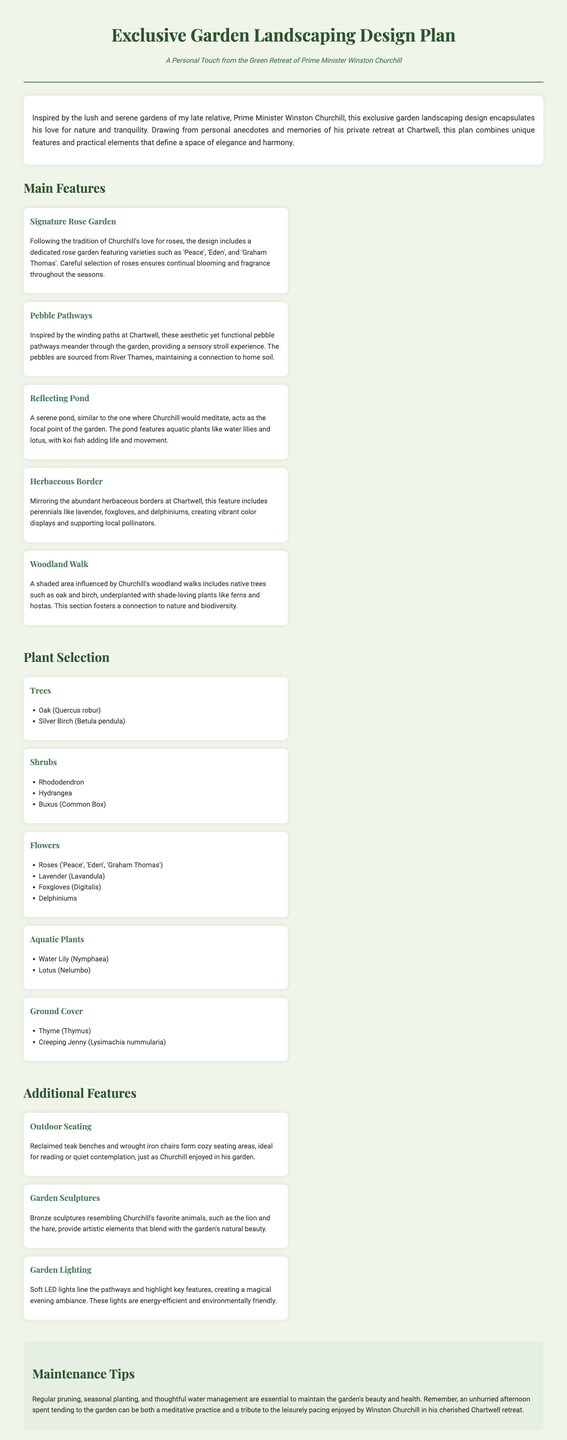What is the title of the document? The title is clearly stated at the top of the document as the heading.
Answer: Exclusive Garden Landscaping Design Plan Who is the subtitle referencing? The subtitle indicates that it references a notable historical figure known for his leadership.
Answer: Prime Minister Winston Churchill What type of garden feature is included for relaxation? The document specifies a seating area that promotes comfort and tranquility.
Answer: Outdoor Seating Which flower variety is mentioned for the rose garden? The document lists specific rose varieties that contribute to the garden's design.
Answer: 'Peace', 'Eden', and 'Graham Thomas' What aquatic plants are included in the reflecting pond? The document names the aquatic plants that enhance the pond's aesthetic.
Answer: Water Lily and Lotus How many main features are presented in the landscaping design? The document outlines a specific number of notable landscaping features.
Answer: Five What maintenance practice is emphasized in the document? The document mentions a critical practice to ensure the garden's upkeep and health.
Answer: Regular pruning What type of trees are listed under plant selection? The document provides specific examples of trees that are part of the overall design.
Answer: Oak and Silver Birch What kind of lighting is specified for the garden? The document details the type of lighting to be used for enhancing the garden's appeal at night.
Answer: Soft LED lights 